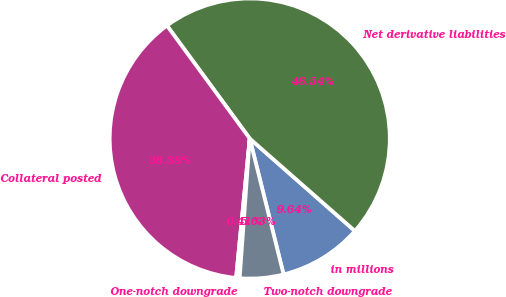<chart> <loc_0><loc_0><loc_500><loc_500><pie_chart><fcel>in millions<fcel>Net derivative liabilities<fcel>Collateral posted<fcel>One-notch downgrade<fcel>Two-notch downgrade<nl><fcel>9.64%<fcel>46.54%<fcel>38.38%<fcel>0.41%<fcel>5.03%<nl></chart> 